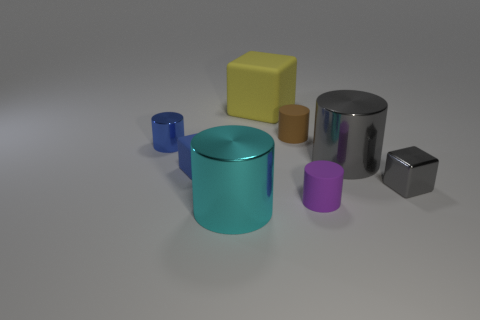Subtract all yellow blocks. How many blocks are left? 2 Subtract all small blocks. How many blocks are left? 1 Subtract 1 blue cylinders. How many objects are left? 7 Subtract all cubes. How many objects are left? 5 Subtract 4 cylinders. How many cylinders are left? 1 Subtract all brown blocks. Subtract all red balls. How many blocks are left? 3 Subtract all purple blocks. How many gray cylinders are left? 1 Subtract all tiny gray objects. Subtract all gray metal cylinders. How many objects are left? 6 Add 8 small blue metal cylinders. How many small blue metal cylinders are left? 9 Add 2 cyan cylinders. How many cyan cylinders exist? 3 